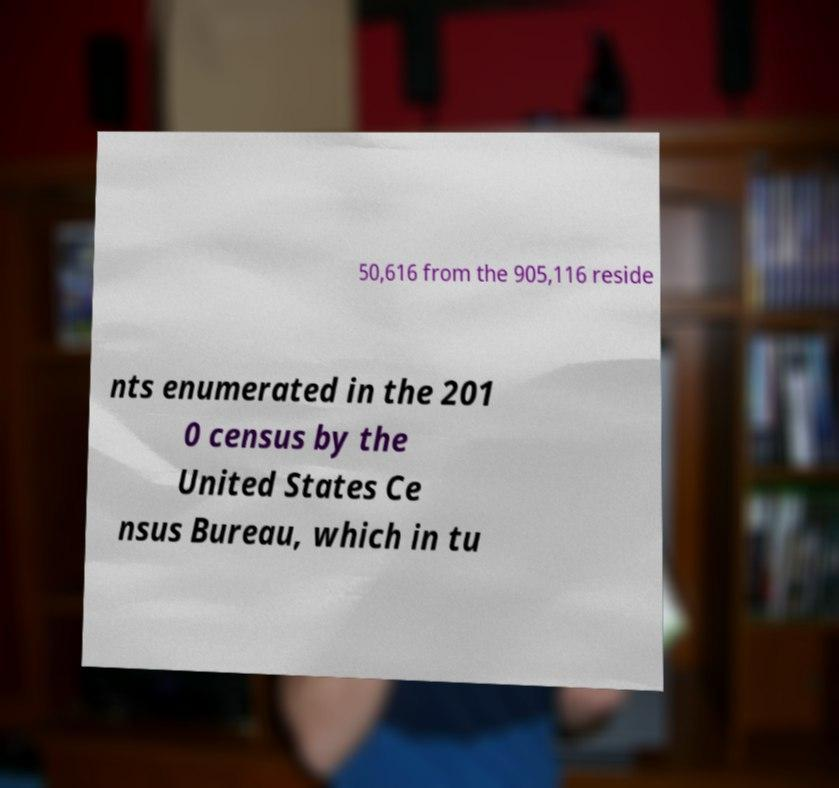Can you read and provide the text displayed in the image?This photo seems to have some interesting text. Can you extract and type it out for me? 50,616 from the 905,116 reside nts enumerated in the 201 0 census by the United States Ce nsus Bureau, which in tu 